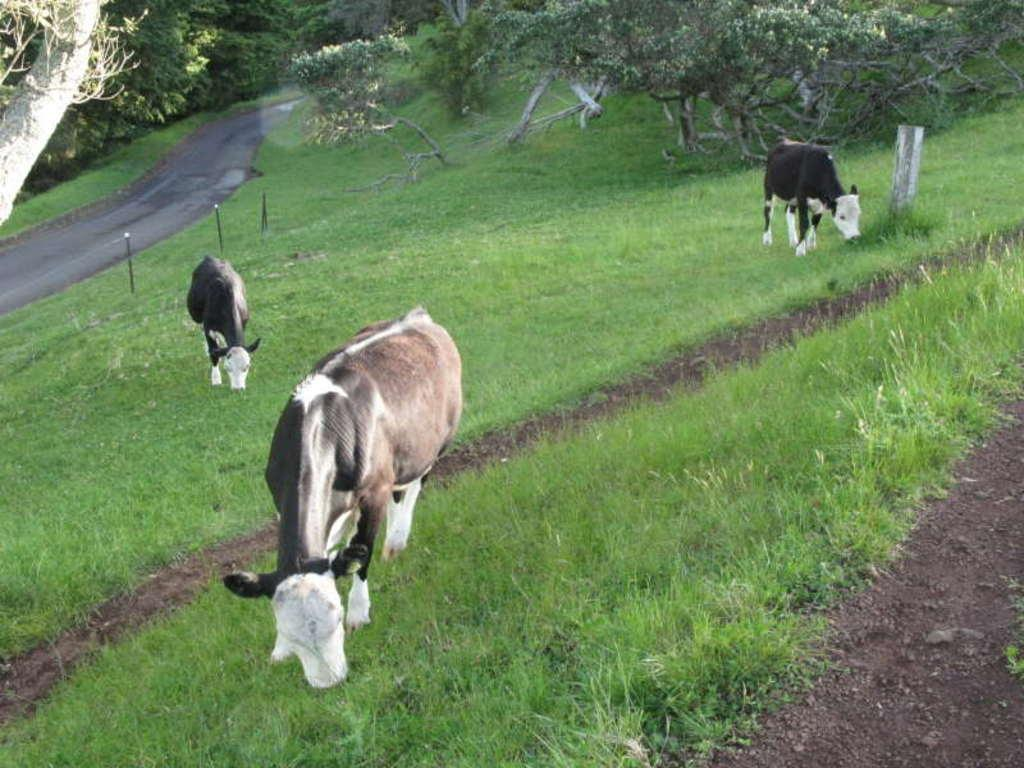How many cows are in the image? There are three cows in the image. What are the cows doing in the image? The cows are standing and eating grass. What can be seen in the image besides the cows? There is a pathway and trees with branches and leaves visible in the image. What type of surface can be seen in the image? There is a road in the image. What type of mask is the cow wearing in the image? There is no mask present on the cows in the image. How much profit did the farmer make from the cows in the image? The image does not provide information about the farmer or any profits made from the cows. 